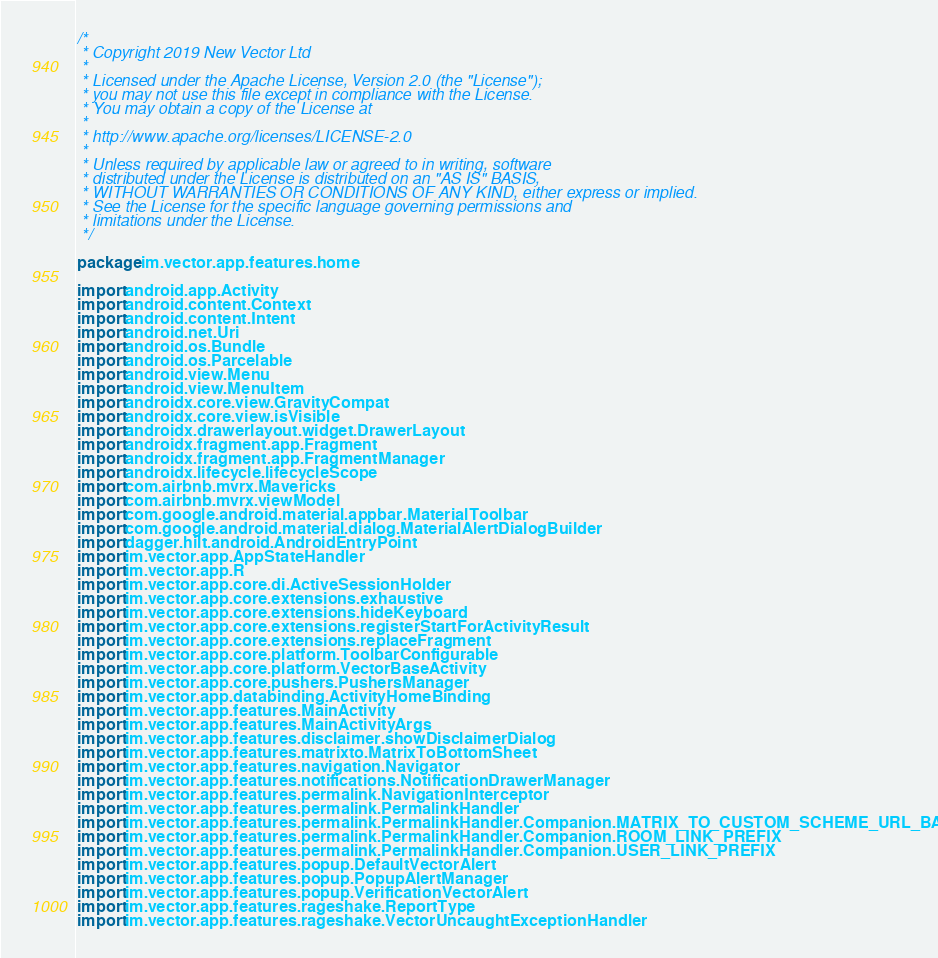Convert code to text. <code><loc_0><loc_0><loc_500><loc_500><_Kotlin_>/*
 * Copyright 2019 New Vector Ltd
 *
 * Licensed under the Apache License, Version 2.0 (the "License");
 * you may not use this file except in compliance with the License.
 * You may obtain a copy of the License at
 *
 * http://www.apache.org/licenses/LICENSE-2.0
 *
 * Unless required by applicable law or agreed to in writing, software
 * distributed under the License is distributed on an "AS IS" BASIS,
 * WITHOUT WARRANTIES OR CONDITIONS OF ANY KIND, either express or implied.
 * See the License for the specific language governing permissions and
 * limitations under the License.
 */

package im.vector.app.features.home

import android.app.Activity
import android.content.Context
import android.content.Intent
import android.net.Uri
import android.os.Bundle
import android.os.Parcelable
import android.view.Menu
import android.view.MenuItem
import androidx.core.view.GravityCompat
import androidx.core.view.isVisible
import androidx.drawerlayout.widget.DrawerLayout
import androidx.fragment.app.Fragment
import androidx.fragment.app.FragmentManager
import androidx.lifecycle.lifecycleScope
import com.airbnb.mvrx.Mavericks
import com.airbnb.mvrx.viewModel
import com.google.android.material.appbar.MaterialToolbar
import com.google.android.material.dialog.MaterialAlertDialogBuilder
import dagger.hilt.android.AndroidEntryPoint
import im.vector.app.AppStateHandler
import im.vector.app.R
import im.vector.app.core.di.ActiveSessionHolder
import im.vector.app.core.extensions.exhaustive
import im.vector.app.core.extensions.hideKeyboard
import im.vector.app.core.extensions.registerStartForActivityResult
import im.vector.app.core.extensions.replaceFragment
import im.vector.app.core.platform.ToolbarConfigurable
import im.vector.app.core.platform.VectorBaseActivity
import im.vector.app.core.pushers.PushersManager
import im.vector.app.databinding.ActivityHomeBinding
import im.vector.app.features.MainActivity
import im.vector.app.features.MainActivityArgs
import im.vector.app.features.disclaimer.showDisclaimerDialog
import im.vector.app.features.matrixto.MatrixToBottomSheet
import im.vector.app.features.navigation.Navigator
import im.vector.app.features.notifications.NotificationDrawerManager
import im.vector.app.features.permalink.NavigationInterceptor
import im.vector.app.features.permalink.PermalinkHandler
import im.vector.app.features.permalink.PermalinkHandler.Companion.MATRIX_TO_CUSTOM_SCHEME_URL_BASE
import im.vector.app.features.permalink.PermalinkHandler.Companion.ROOM_LINK_PREFIX
import im.vector.app.features.permalink.PermalinkHandler.Companion.USER_LINK_PREFIX
import im.vector.app.features.popup.DefaultVectorAlert
import im.vector.app.features.popup.PopupAlertManager
import im.vector.app.features.popup.VerificationVectorAlert
import im.vector.app.features.rageshake.ReportType
import im.vector.app.features.rageshake.VectorUncaughtExceptionHandler</code> 